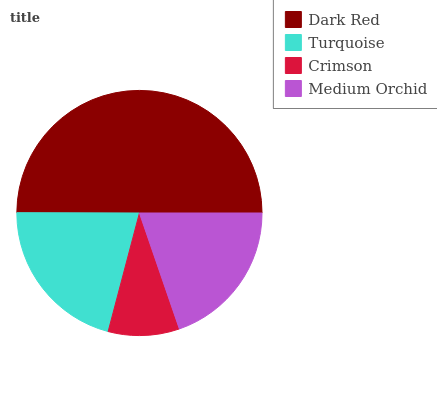Is Crimson the minimum?
Answer yes or no. Yes. Is Dark Red the maximum?
Answer yes or no. Yes. Is Turquoise the minimum?
Answer yes or no. No. Is Turquoise the maximum?
Answer yes or no. No. Is Dark Red greater than Turquoise?
Answer yes or no. Yes. Is Turquoise less than Dark Red?
Answer yes or no. Yes. Is Turquoise greater than Dark Red?
Answer yes or no. No. Is Dark Red less than Turquoise?
Answer yes or no. No. Is Turquoise the high median?
Answer yes or no. Yes. Is Medium Orchid the low median?
Answer yes or no. Yes. Is Dark Red the high median?
Answer yes or no. No. Is Crimson the low median?
Answer yes or no. No. 